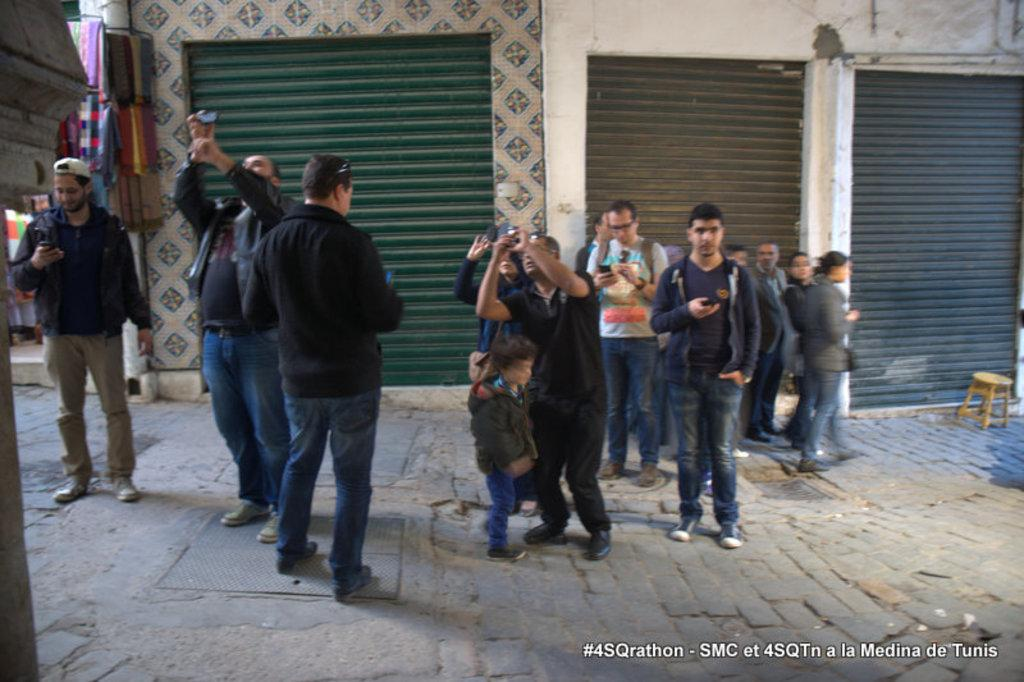What are the people in the image doing? The people in the image are standing and holding something. What type of objects can be seen in the image? There are shutters, stools, and a wall visible in the image. Can you describe the objects being held by the people? Unfortunately, the specific objects being held cannot be determined from the provided facts. What is the purpose of the stool in the image? The purpose of the stool cannot be determined from the provided facts. What type of comb is being used by the governor in the image? There is no governor or comb present in the image. How many trucks can be seen in the image? There are no trucks visible in the image. 